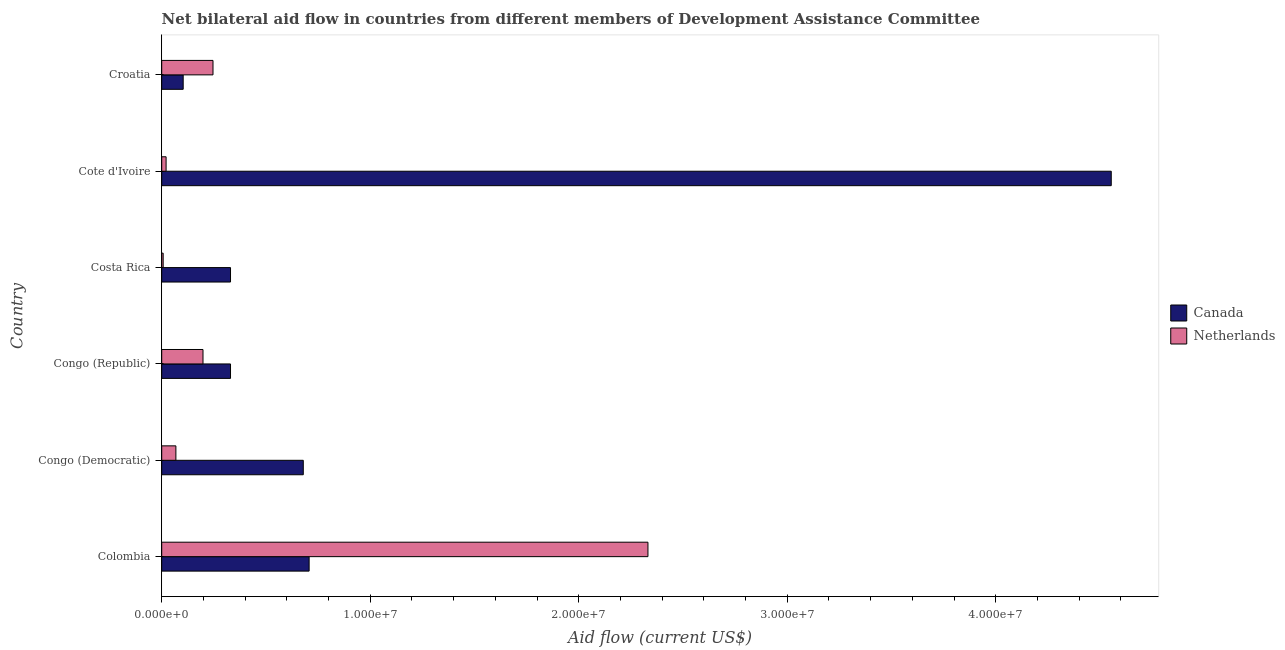Are the number of bars on each tick of the Y-axis equal?
Keep it short and to the point. Yes. How many bars are there on the 6th tick from the top?
Your response must be concise. 2. How many bars are there on the 4th tick from the bottom?
Ensure brevity in your answer.  2. What is the label of the 4th group of bars from the top?
Your answer should be very brief. Congo (Republic). What is the amount of aid given by netherlands in Colombia?
Your response must be concise. 2.33e+07. Across all countries, what is the maximum amount of aid given by netherlands?
Make the answer very short. 2.33e+07. Across all countries, what is the minimum amount of aid given by netherlands?
Give a very brief answer. 7.00e+04. In which country was the amount of aid given by canada maximum?
Your answer should be very brief. Cote d'Ivoire. In which country was the amount of aid given by netherlands minimum?
Provide a short and direct response. Costa Rica. What is the total amount of aid given by netherlands in the graph?
Give a very brief answer. 2.87e+07. What is the difference between the amount of aid given by canada in Congo (Democratic) and that in Croatia?
Offer a terse response. 5.76e+06. What is the difference between the amount of aid given by netherlands in Costa Rica and the amount of aid given by canada in Cote d'Ivoire?
Make the answer very short. -4.55e+07. What is the average amount of aid given by netherlands per country?
Make the answer very short. 4.79e+06. What is the difference between the amount of aid given by canada and amount of aid given by netherlands in Congo (Republic)?
Keep it short and to the point. 1.32e+06. In how many countries, is the amount of aid given by canada greater than 40000000 US$?
Provide a short and direct response. 1. What is the ratio of the amount of aid given by netherlands in Costa Rica to that in Croatia?
Provide a succinct answer. 0.03. Is the difference between the amount of aid given by netherlands in Congo (Democratic) and Costa Rica greater than the difference between the amount of aid given by canada in Congo (Democratic) and Costa Rica?
Make the answer very short. No. What is the difference between the highest and the second highest amount of aid given by netherlands?
Offer a very short reply. 2.09e+07. What is the difference between the highest and the lowest amount of aid given by netherlands?
Your response must be concise. 2.32e+07. Is the sum of the amount of aid given by netherlands in Colombia and Croatia greater than the maximum amount of aid given by canada across all countries?
Your answer should be compact. No. What does the 1st bar from the bottom in Colombia represents?
Offer a very short reply. Canada. What is the difference between two consecutive major ticks on the X-axis?
Your response must be concise. 1.00e+07. Are the values on the major ticks of X-axis written in scientific E-notation?
Provide a short and direct response. Yes. Does the graph contain any zero values?
Your answer should be compact. No. Does the graph contain grids?
Your answer should be compact. No. Where does the legend appear in the graph?
Your response must be concise. Center right. How many legend labels are there?
Ensure brevity in your answer.  2. How are the legend labels stacked?
Provide a succinct answer. Vertical. What is the title of the graph?
Ensure brevity in your answer.  Net bilateral aid flow in countries from different members of Development Assistance Committee. Does "Male entrants" appear as one of the legend labels in the graph?
Keep it short and to the point. No. What is the Aid flow (current US$) of Canada in Colombia?
Keep it short and to the point. 7.07e+06. What is the Aid flow (current US$) in Netherlands in Colombia?
Give a very brief answer. 2.33e+07. What is the Aid flow (current US$) of Canada in Congo (Democratic)?
Make the answer very short. 6.79e+06. What is the Aid flow (current US$) of Netherlands in Congo (Democratic)?
Offer a very short reply. 6.80e+05. What is the Aid flow (current US$) of Canada in Congo (Republic)?
Your answer should be very brief. 3.30e+06. What is the Aid flow (current US$) in Netherlands in Congo (Republic)?
Your answer should be compact. 1.98e+06. What is the Aid flow (current US$) in Canada in Costa Rica?
Provide a succinct answer. 3.30e+06. What is the Aid flow (current US$) of Netherlands in Costa Rica?
Your response must be concise. 7.00e+04. What is the Aid flow (current US$) of Canada in Cote d'Ivoire?
Provide a succinct answer. 4.55e+07. What is the Aid flow (current US$) in Netherlands in Cote d'Ivoire?
Ensure brevity in your answer.  2.10e+05. What is the Aid flow (current US$) in Canada in Croatia?
Your answer should be compact. 1.03e+06. What is the Aid flow (current US$) in Netherlands in Croatia?
Give a very brief answer. 2.46e+06. Across all countries, what is the maximum Aid flow (current US$) of Canada?
Your response must be concise. 4.55e+07. Across all countries, what is the maximum Aid flow (current US$) in Netherlands?
Your response must be concise. 2.33e+07. Across all countries, what is the minimum Aid flow (current US$) of Canada?
Make the answer very short. 1.03e+06. What is the total Aid flow (current US$) in Canada in the graph?
Provide a succinct answer. 6.70e+07. What is the total Aid flow (current US$) of Netherlands in the graph?
Offer a terse response. 2.87e+07. What is the difference between the Aid flow (current US$) in Canada in Colombia and that in Congo (Democratic)?
Your answer should be compact. 2.80e+05. What is the difference between the Aid flow (current US$) in Netherlands in Colombia and that in Congo (Democratic)?
Provide a succinct answer. 2.26e+07. What is the difference between the Aid flow (current US$) of Canada in Colombia and that in Congo (Republic)?
Provide a succinct answer. 3.77e+06. What is the difference between the Aid flow (current US$) of Netherlands in Colombia and that in Congo (Republic)?
Offer a terse response. 2.13e+07. What is the difference between the Aid flow (current US$) in Canada in Colombia and that in Costa Rica?
Give a very brief answer. 3.77e+06. What is the difference between the Aid flow (current US$) of Netherlands in Colombia and that in Costa Rica?
Keep it short and to the point. 2.32e+07. What is the difference between the Aid flow (current US$) in Canada in Colombia and that in Cote d'Ivoire?
Make the answer very short. -3.85e+07. What is the difference between the Aid flow (current US$) of Netherlands in Colombia and that in Cote d'Ivoire?
Keep it short and to the point. 2.31e+07. What is the difference between the Aid flow (current US$) in Canada in Colombia and that in Croatia?
Your response must be concise. 6.04e+06. What is the difference between the Aid flow (current US$) in Netherlands in Colombia and that in Croatia?
Your response must be concise. 2.09e+07. What is the difference between the Aid flow (current US$) in Canada in Congo (Democratic) and that in Congo (Republic)?
Provide a short and direct response. 3.49e+06. What is the difference between the Aid flow (current US$) of Netherlands in Congo (Democratic) and that in Congo (Republic)?
Keep it short and to the point. -1.30e+06. What is the difference between the Aid flow (current US$) of Canada in Congo (Democratic) and that in Costa Rica?
Offer a terse response. 3.49e+06. What is the difference between the Aid flow (current US$) in Canada in Congo (Democratic) and that in Cote d'Ivoire?
Your answer should be very brief. -3.88e+07. What is the difference between the Aid flow (current US$) in Canada in Congo (Democratic) and that in Croatia?
Your response must be concise. 5.76e+06. What is the difference between the Aid flow (current US$) in Netherlands in Congo (Democratic) and that in Croatia?
Give a very brief answer. -1.78e+06. What is the difference between the Aid flow (current US$) in Canada in Congo (Republic) and that in Costa Rica?
Give a very brief answer. 0. What is the difference between the Aid flow (current US$) of Netherlands in Congo (Republic) and that in Costa Rica?
Provide a succinct answer. 1.91e+06. What is the difference between the Aid flow (current US$) of Canada in Congo (Republic) and that in Cote d'Ivoire?
Your answer should be very brief. -4.22e+07. What is the difference between the Aid flow (current US$) of Netherlands in Congo (Republic) and that in Cote d'Ivoire?
Make the answer very short. 1.77e+06. What is the difference between the Aid flow (current US$) in Canada in Congo (Republic) and that in Croatia?
Keep it short and to the point. 2.27e+06. What is the difference between the Aid flow (current US$) in Netherlands in Congo (Republic) and that in Croatia?
Offer a very short reply. -4.80e+05. What is the difference between the Aid flow (current US$) of Canada in Costa Rica and that in Cote d'Ivoire?
Your answer should be very brief. -4.22e+07. What is the difference between the Aid flow (current US$) of Canada in Costa Rica and that in Croatia?
Give a very brief answer. 2.27e+06. What is the difference between the Aid flow (current US$) of Netherlands in Costa Rica and that in Croatia?
Provide a short and direct response. -2.39e+06. What is the difference between the Aid flow (current US$) of Canada in Cote d'Ivoire and that in Croatia?
Ensure brevity in your answer.  4.45e+07. What is the difference between the Aid flow (current US$) of Netherlands in Cote d'Ivoire and that in Croatia?
Make the answer very short. -2.25e+06. What is the difference between the Aid flow (current US$) in Canada in Colombia and the Aid flow (current US$) in Netherlands in Congo (Democratic)?
Provide a short and direct response. 6.39e+06. What is the difference between the Aid flow (current US$) in Canada in Colombia and the Aid flow (current US$) in Netherlands in Congo (Republic)?
Give a very brief answer. 5.09e+06. What is the difference between the Aid flow (current US$) of Canada in Colombia and the Aid flow (current US$) of Netherlands in Costa Rica?
Offer a terse response. 7.00e+06. What is the difference between the Aid flow (current US$) in Canada in Colombia and the Aid flow (current US$) in Netherlands in Cote d'Ivoire?
Offer a very short reply. 6.86e+06. What is the difference between the Aid flow (current US$) of Canada in Colombia and the Aid flow (current US$) of Netherlands in Croatia?
Your answer should be very brief. 4.61e+06. What is the difference between the Aid flow (current US$) of Canada in Congo (Democratic) and the Aid flow (current US$) of Netherlands in Congo (Republic)?
Offer a terse response. 4.81e+06. What is the difference between the Aid flow (current US$) of Canada in Congo (Democratic) and the Aid flow (current US$) of Netherlands in Costa Rica?
Your answer should be compact. 6.72e+06. What is the difference between the Aid flow (current US$) in Canada in Congo (Democratic) and the Aid flow (current US$) in Netherlands in Cote d'Ivoire?
Make the answer very short. 6.58e+06. What is the difference between the Aid flow (current US$) of Canada in Congo (Democratic) and the Aid flow (current US$) of Netherlands in Croatia?
Provide a succinct answer. 4.33e+06. What is the difference between the Aid flow (current US$) in Canada in Congo (Republic) and the Aid flow (current US$) in Netherlands in Costa Rica?
Your response must be concise. 3.23e+06. What is the difference between the Aid flow (current US$) of Canada in Congo (Republic) and the Aid flow (current US$) of Netherlands in Cote d'Ivoire?
Give a very brief answer. 3.09e+06. What is the difference between the Aid flow (current US$) of Canada in Congo (Republic) and the Aid flow (current US$) of Netherlands in Croatia?
Your response must be concise. 8.40e+05. What is the difference between the Aid flow (current US$) of Canada in Costa Rica and the Aid flow (current US$) of Netherlands in Cote d'Ivoire?
Provide a short and direct response. 3.09e+06. What is the difference between the Aid flow (current US$) of Canada in Costa Rica and the Aid flow (current US$) of Netherlands in Croatia?
Make the answer very short. 8.40e+05. What is the difference between the Aid flow (current US$) of Canada in Cote d'Ivoire and the Aid flow (current US$) of Netherlands in Croatia?
Provide a short and direct response. 4.31e+07. What is the average Aid flow (current US$) in Canada per country?
Provide a short and direct response. 1.12e+07. What is the average Aid flow (current US$) of Netherlands per country?
Keep it short and to the point. 4.79e+06. What is the difference between the Aid flow (current US$) in Canada and Aid flow (current US$) in Netherlands in Colombia?
Keep it short and to the point. -1.62e+07. What is the difference between the Aid flow (current US$) of Canada and Aid flow (current US$) of Netherlands in Congo (Democratic)?
Your answer should be compact. 6.11e+06. What is the difference between the Aid flow (current US$) of Canada and Aid flow (current US$) of Netherlands in Congo (Republic)?
Offer a terse response. 1.32e+06. What is the difference between the Aid flow (current US$) in Canada and Aid flow (current US$) in Netherlands in Costa Rica?
Keep it short and to the point. 3.23e+06. What is the difference between the Aid flow (current US$) in Canada and Aid flow (current US$) in Netherlands in Cote d'Ivoire?
Provide a succinct answer. 4.53e+07. What is the difference between the Aid flow (current US$) of Canada and Aid flow (current US$) of Netherlands in Croatia?
Your answer should be compact. -1.43e+06. What is the ratio of the Aid flow (current US$) in Canada in Colombia to that in Congo (Democratic)?
Give a very brief answer. 1.04. What is the ratio of the Aid flow (current US$) of Netherlands in Colombia to that in Congo (Democratic)?
Ensure brevity in your answer.  34.29. What is the ratio of the Aid flow (current US$) of Canada in Colombia to that in Congo (Republic)?
Ensure brevity in your answer.  2.14. What is the ratio of the Aid flow (current US$) of Netherlands in Colombia to that in Congo (Republic)?
Offer a terse response. 11.78. What is the ratio of the Aid flow (current US$) in Canada in Colombia to that in Costa Rica?
Offer a terse response. 2.14. What is the ratio of the Aid flow (current US$) of Netherlands in Colombia to that in Costa Rica?
Provide a short and direct response. 333.14. What is the ratio of the Aid flow (current US$) in Canada in Colombia to that in Cote d'Ivoire?
Provide a succinct answer. 0.16. What is the ratio of the Aid flow (current US$) in Netherlands in Colombia to that in Cote d'Ivoire?
Ensure brevity in your answer.  111.05. What is the ratio of the Aid flow (current US$) of Canada in Colombia to that in Croatia?
Make the answer very short. 6.86. What is the ratio of the Aid flow (current US$) of Netherlands in Colombia to that in Croatia?
Provide a succinct answer. 9.48. What is the ratio of the Aid flow (current US$) of Canada in Congo (Democratic) to that in Congo (Republic)?
Offer a very short reply. 2.06. What is the ratio of the Aid flow (current US$) of Netherlands in Congo (Democratic) to that in Congo (Republic)?
Provide a succinct answer. 0.34. What is the ratio of the Aid flow (current US$) in Canada in Congo (Democratic) to that in Costa Rica?
Give a very brief answer. 2.06. What is the ratio of the Aid flow (current US$) of Netherlands in Congo (Democratic) to that in Costa Rica?
Keep it short and to the point. 9.71. What is the ratio of the Aid flow (current US$) in Canada in Congo (Democratic) to that in Cote d'Ivoire?
Your answer should be very brief. 0.15. What is the ratio of the Aid flow (current US$) in Netherlands in Congo (Democratic) to that in Cote d'Ivoire?
Provide a succinct answer. 3.24. What is the ratio of the Aid flow (current US$) in Canada in Congo (Democratic) to that in Croatia?
Your answer should be very brief. 6.59. What is the ratio of the Aid flow (current US$) of Netherlands in Congo (Democratic) to that in Croatia?
Make the answer very short. 0.28. What is the ratio of the Aid flow (current US$) in Netherlands in Congo (Republic) to that in Costa Rica?
Your answer should be compact. 28.29. What is the ratio of the Aid flow (current US$) of Canada in Congo (Republic) to that in Cote d'Ivoire?
Your answer should be very brief. 0.07. What is the ratio of the Aid flow (current US$) of Netherlands in Congo (Republic) to that in Cote d'Ivoire?
Give a very brief answer. 9.43. What is the ratio of the Aid flow (current US$) of Canada in Congo (Republic) to that in Croatia?
Your answer should be very brief. 3.2. What is the ratio of the Aid flow (current US$) in Netherlands in Congo (Republic) to that in Croatia?
Keep it short and to the point. 0.8. What is the ratio of the Aid flow (current US$) in Canada in Costa Rica to that in Cote d'Ivoire?
Give a very brief answer. 0.07. What is the ratio of the Aid flow (current US$) of Canada in Costa Rica to that in Croatia?
Your answer should be compact. 3.2. What is the ratio of the Aid flow (current US$) of Netherlands in Costa Rica to that in Croatia?
Provide a short and direct response. 0.03. What is the ratio of the Aid flow (current US$) in Canada in Cote d'Ivoire to that in Croatia?
Offer a terse response. 44.21. What is the ratio of the Aid flow (current US$) in Netherlands in Cote d'Ivoire to that in Croatia?
Your answer should be compact. 0.09. What is the difference between the highest and the second highest Aid flow (current US$) in Canada?
Make the answer very short. 3.85e+07. What is the difference between the highest and the second highest Aid flow (current US$) of Netherlands?
Offer a very short reply. 2.09e+07. What is the difference between the highest and the lowest Aid flow (current US$) of Canada?
Offer a very short reply. 4.45e+07. What is the difference between the highest and the lowest Aid flow (current US$) of Netherlands?
Give a very brief answer. 2.32e+07. 